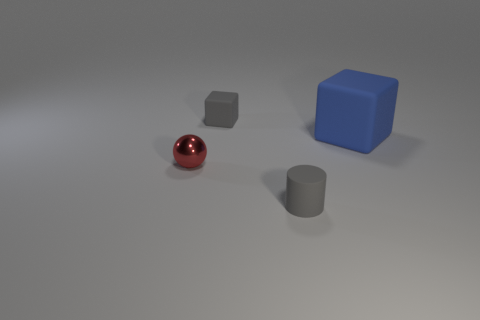Is there any other thing that is made of the same material as the ball?
Make the answer very short. No. Are there any other things that have the same size as the blue rubber object?
Your response must be concise. No. Is there anything else that has the same shape as the red object?
Your response must be concise. No. What is the material of the object that is the same color as the small rubber cube?
Offer a very short reply. Rubber. There is a gray object that is in front of the large matte thing; how many spheres are left of it?
Provide a short and direct response. 1. Are there any rubber objects that have the same color as the small rubber cylinder?
Provide a short and direct response. Yes. Do the red metallic object and the gray rubber cube have the same size?
Keep it short and to the point. Yes. Is the tiny rubber cylinder the same color as the tiny rubber cube?
Provide a succinct answer. Yes. What is the material of the blue thing that is on the right side of the matte cube that is to the left of the large blue matte object?
Offer a terse response. Rubber. What material is the other small object that is the same shape as the blue rubber thing?
Your answer should be very brief. Rubber. 